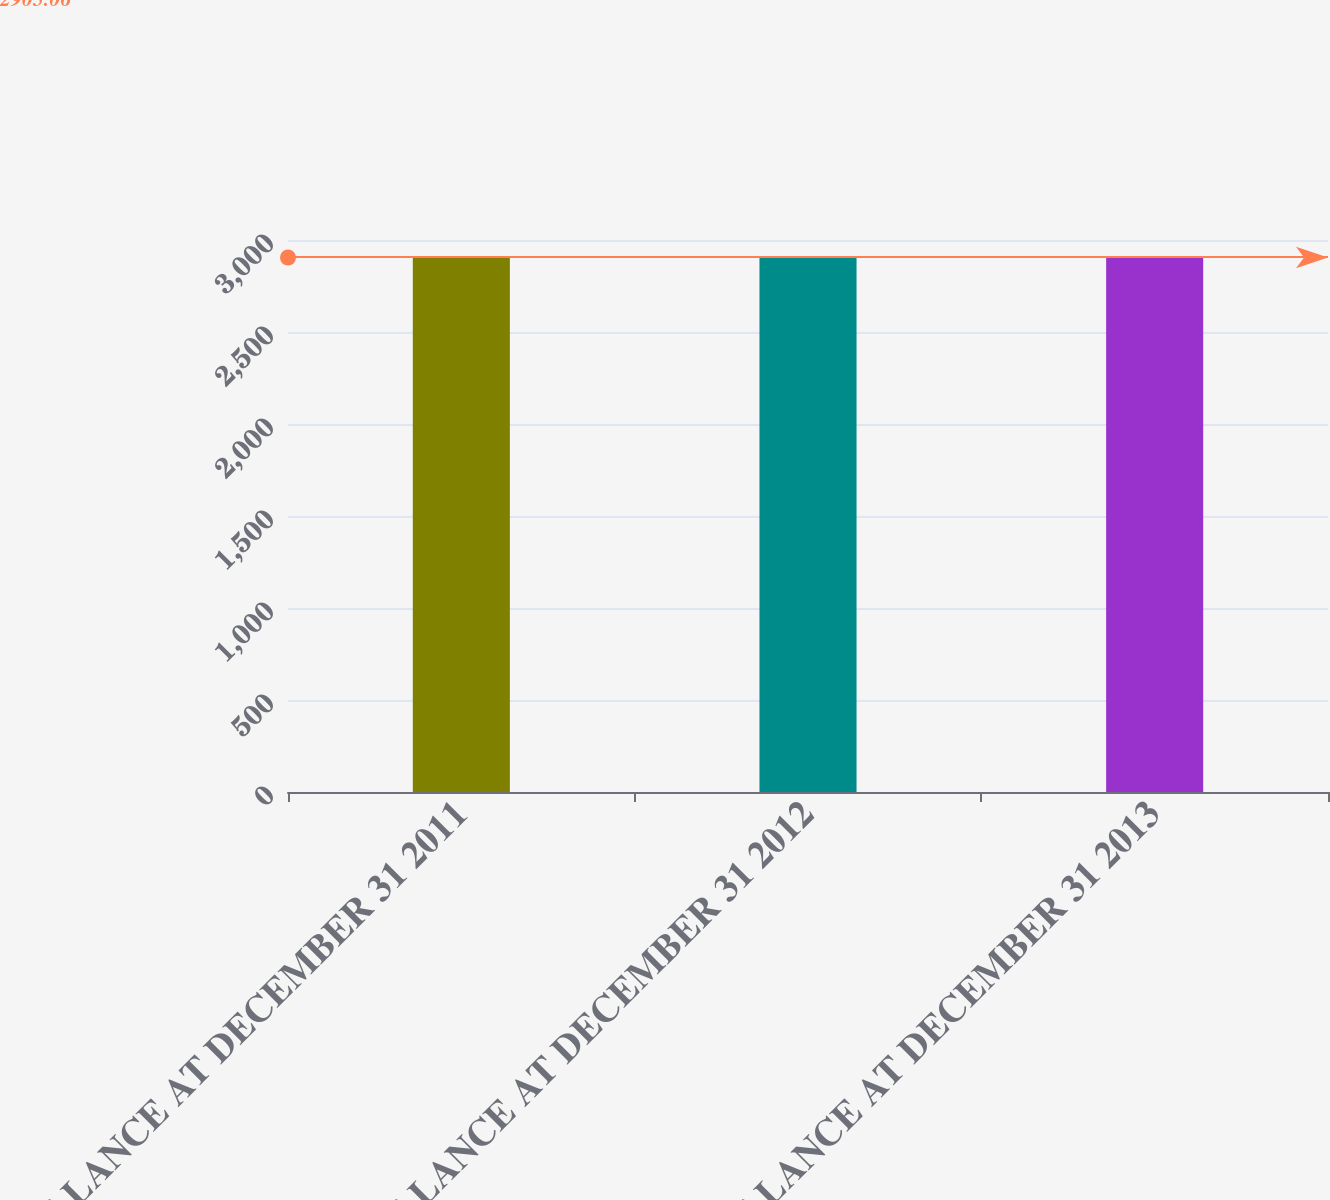<chart> <loc_0><loc_0><loc_500><loc_500><bar_chart><fcel>BALANCE AT DECEMBER 31 2011<fcel>BALANCE AT DECEMBER 31 2012<fcel>BALANCE AT DECEMBER 31 2013<nl><fcel>2905<fcel>2905.1<fcel>2905.2<nl></chart> 